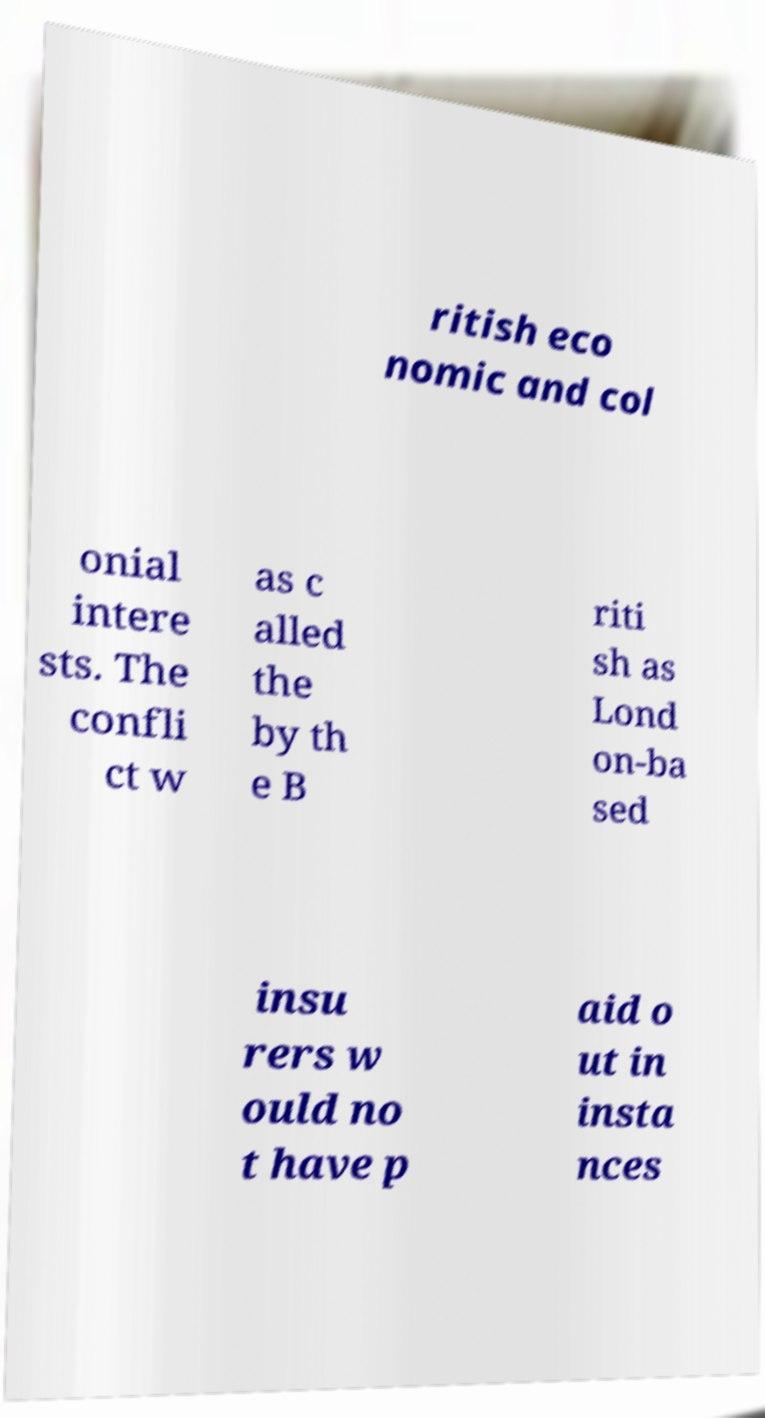For documentation purposes, I need the text within this image transcribed. Could you provide that? ritish eco nomic and col onial intere sts. The confli ct w as c alled the by th e B riti sh as Lond on-ba sed insu rers w ould no t have p aid o ut in insta nces 